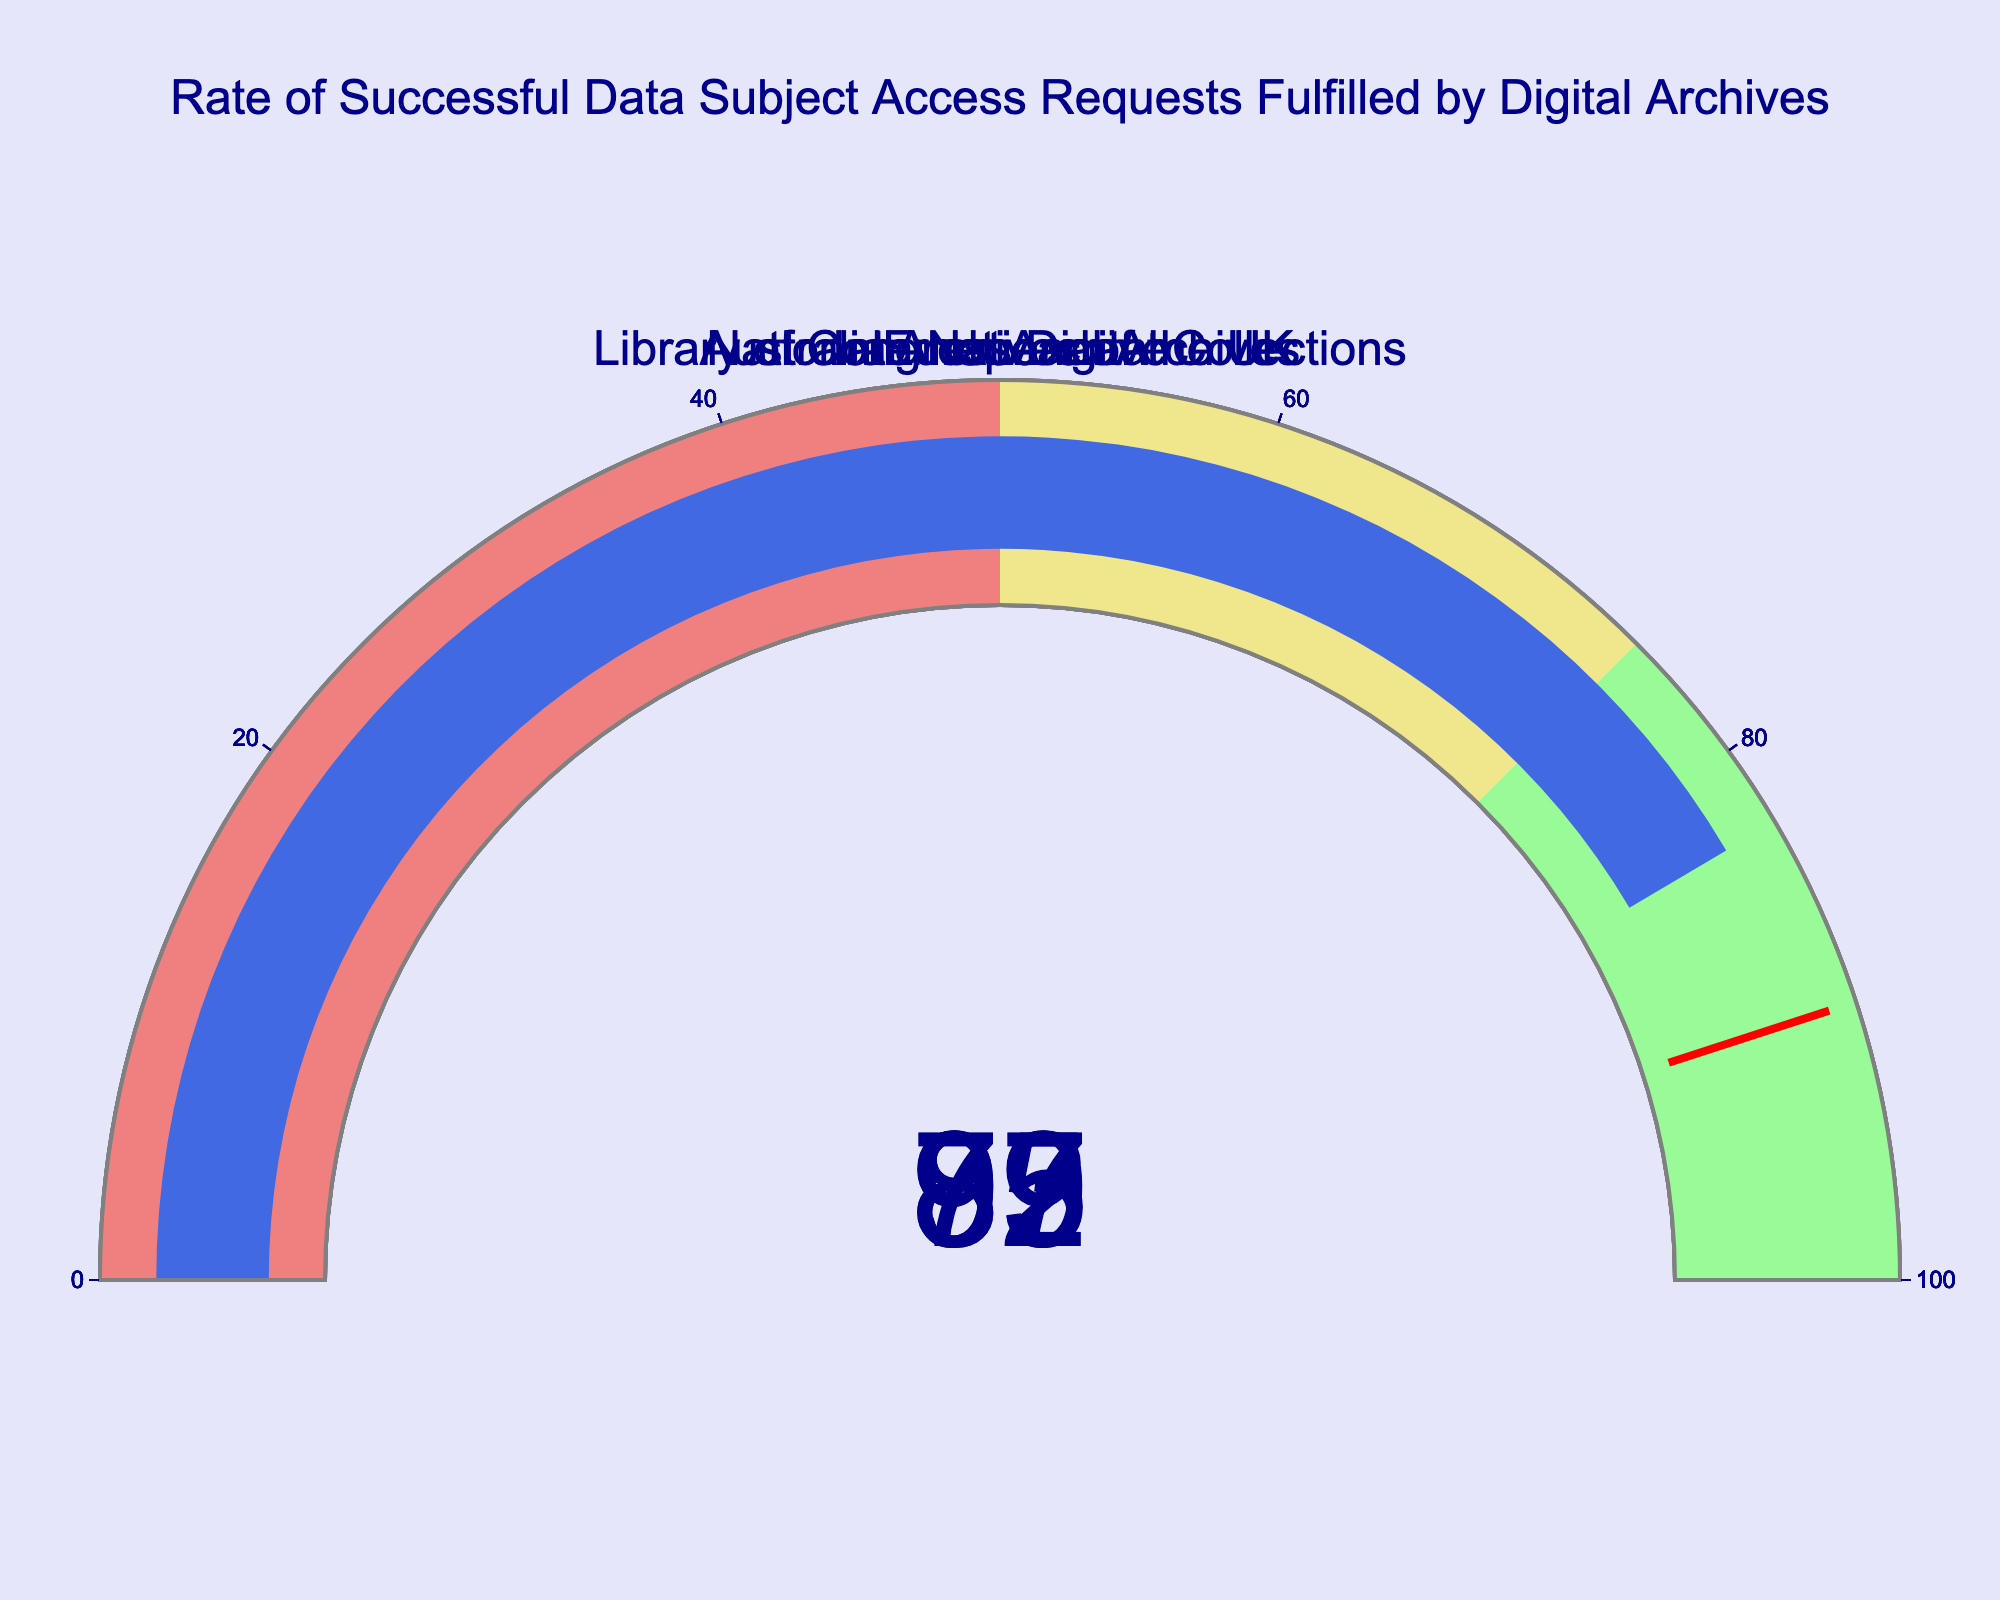What's the title of the figure? The title of the figure is displayed at the top in a large font. It reads "Rate of Successful Data Subject Access Requests Fulfilled by Digital Archives".
Answer: Rate of Successful Data Subject Access Requests Fulfilled by Digital Archives How many digital archives are displayed in the figure? The figure shows multiple gauges, each corresponding to a different digital archive. By counting them, we see there are 5 in total: "National Archives of the UK", "Library of Congress Digital Collections", "Europeana", "Internet Archive", and "Australian National Archives".
Answer: 5 Which digital archive has the highest success rate? Looking at the gauge with the highest value, the "Internet Archive" has the highest success rate at 95.
Answer: Internet Archive What is the success rate for the "Library of Congress Digital Collections"? By referring to the gauge labeled "Library of Congress Digital Collections", we see the success rate is shown as 92.
Answer: 92 Which digital archive falls within the 'lightcoral' range? The 'lightcoral' range on the gauge corresponds to a success rate of less than 50. By checking each gauge, we see no digital archive falls within this range.
Answer: None What is the difference in the success rate between the "National Archives of the UK" and "Australian National Archives"? The success rate for "National Archives of the UK" is 87 and for "Australian National Archives" is 83. Subtracting these gives 87 - 83 = 4.
Answer: 4 What is the average success rate of all digital archives? Sum the success rates of all archives and divide by the number of archives (87 + 92 + 79 + 95 + 83)/5 = 436/5 = 87.2.
Answer: 87.2 Which digital archive is closest to the threshold value of 90? The threshold line in the gauge represents a value of 90. By checking the values, "Library of Congress Digital Collections" has a success rate of 92, which is closest to 90.
Answer: Library of Congress Digital Collections What is the success rate range represented by the color 'khaki' in the gauges? The 'khaki' color in each gauge represents the range from 50 to 75.
Answer: 50 to 75 What is the difference between the highest and the lowest success rates displayed? The highest success rate is 95 ("Internet Archive") and the lowest is 79 ("Europeana"). Subtracting these gives 95 - 79 = 16.
Answer: 16 